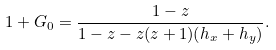Convert formula to latex. <formula><loc_0><loc_0><loc_500><loc_500>1 + G _ { 0 } = \frac { 1 - z } { 1 - z - z ( z + 1 ) ( h _ { x } + h _ { y } ) } .</formula> 